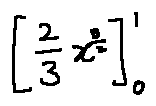Convert formula to latex. <formula><loc_0><loc_0><loc_500><loc_500>[ \frac { 2 } { 3 } x ^ { \frac { 3 } { 2 } } ] _ { 0 } ^ { 1 }</formula> 